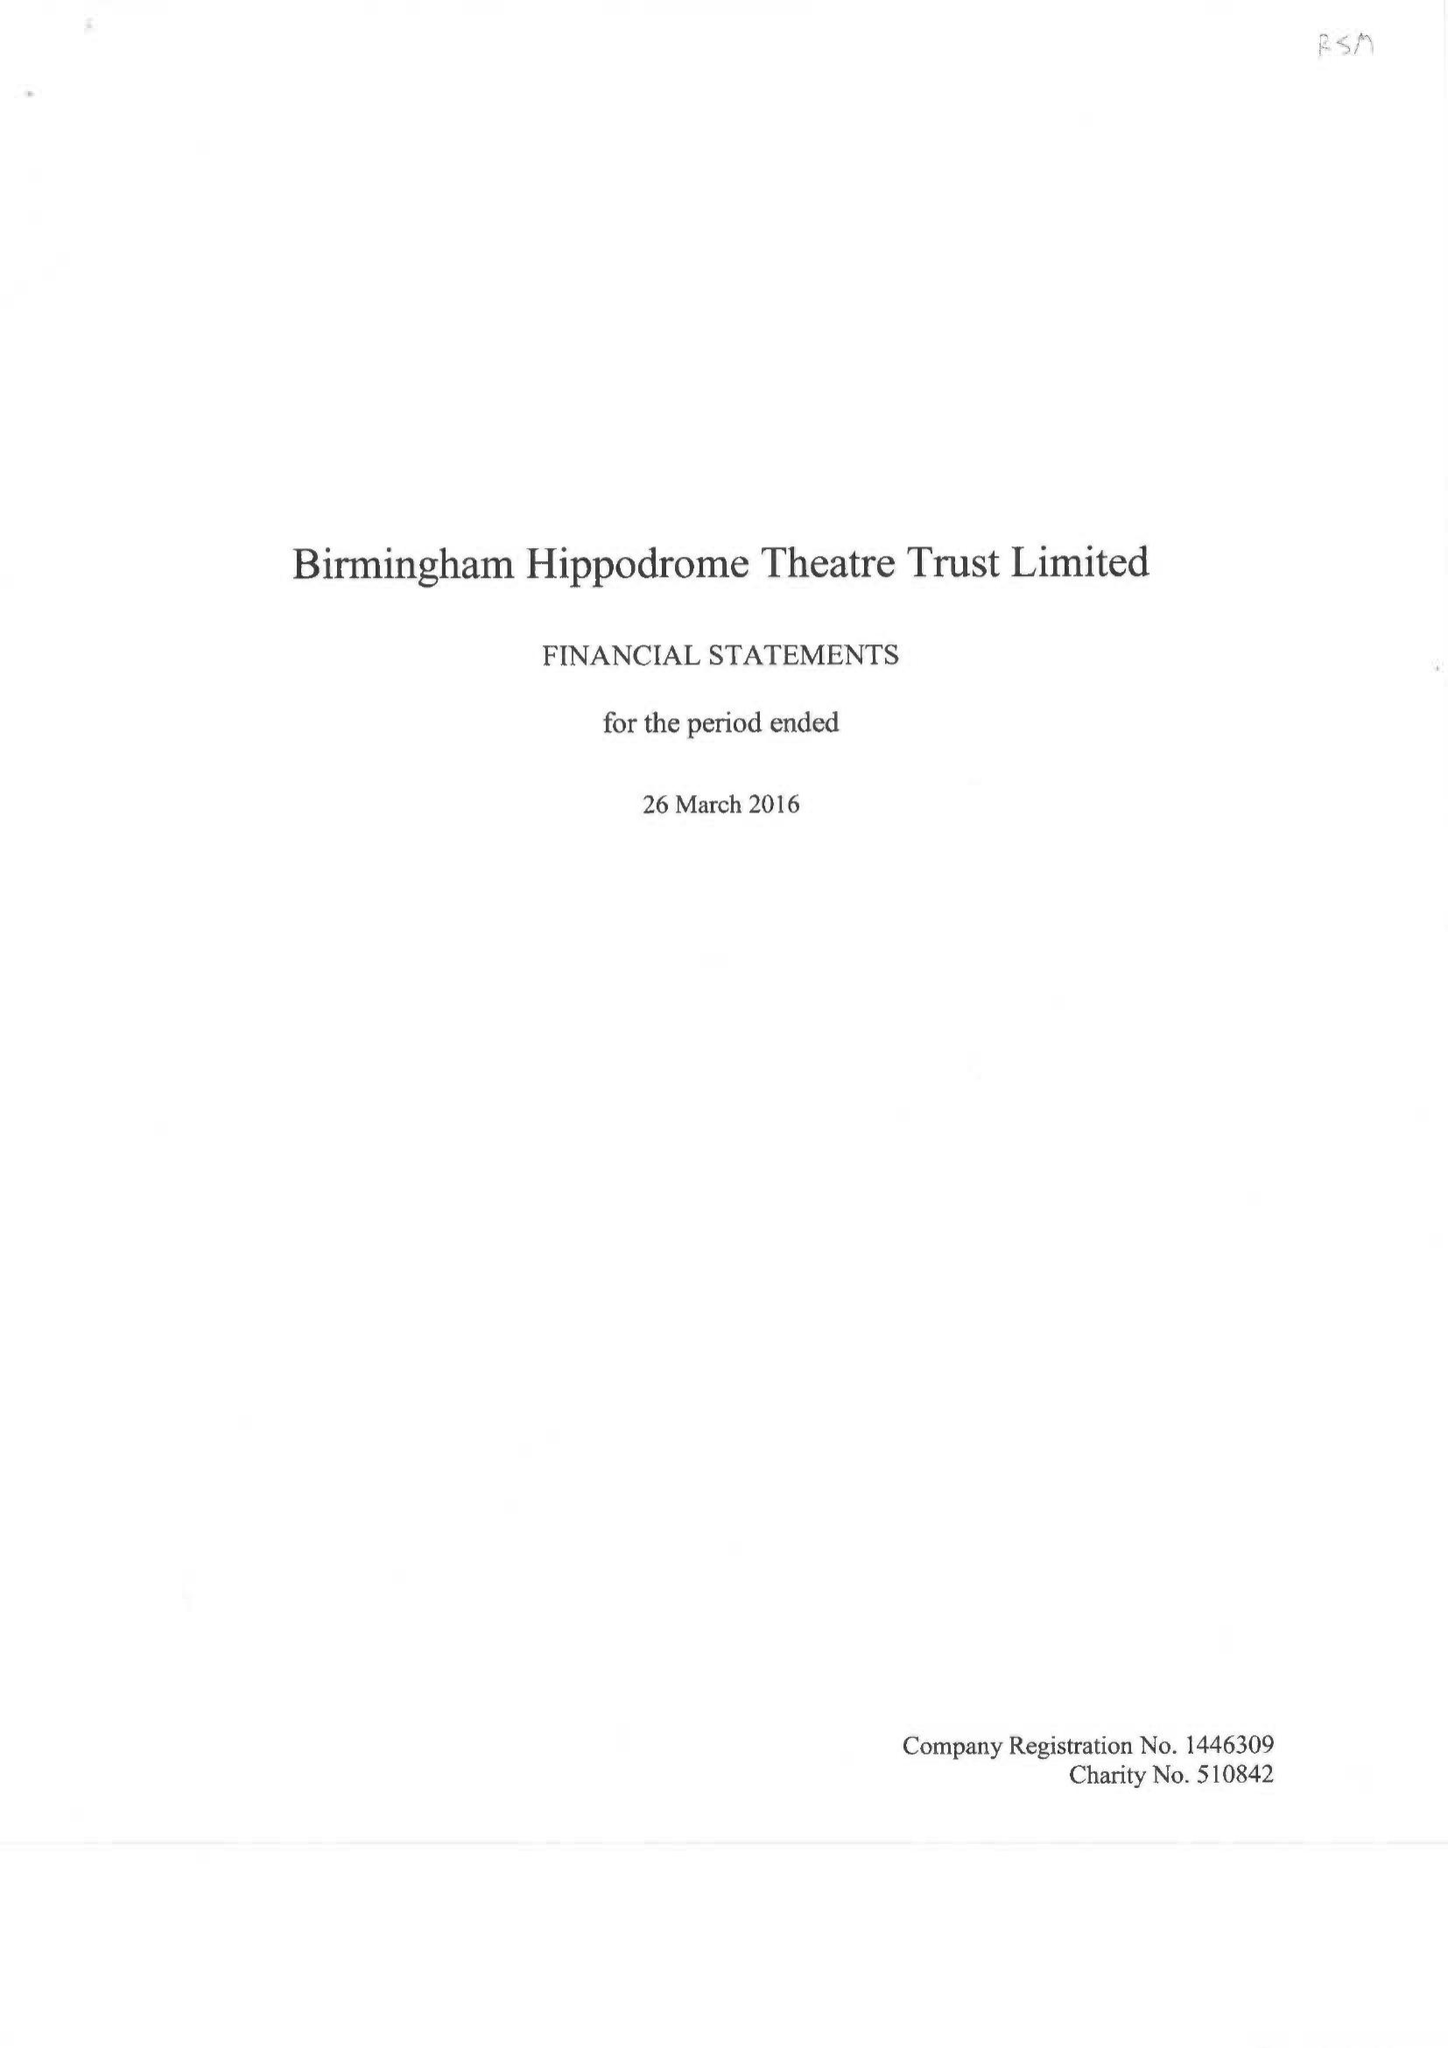What is the value for the income_annually_in_british_pounds?
Answer the question using a single word or phrase. 24803000.00 